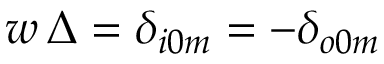Convert formula to latex. <formula><loc_0><loc_0><loc_500><loc_500>w \, \Delta = \delta _ { i 0 m } = - \delta _ { o 0 m }</formula> 